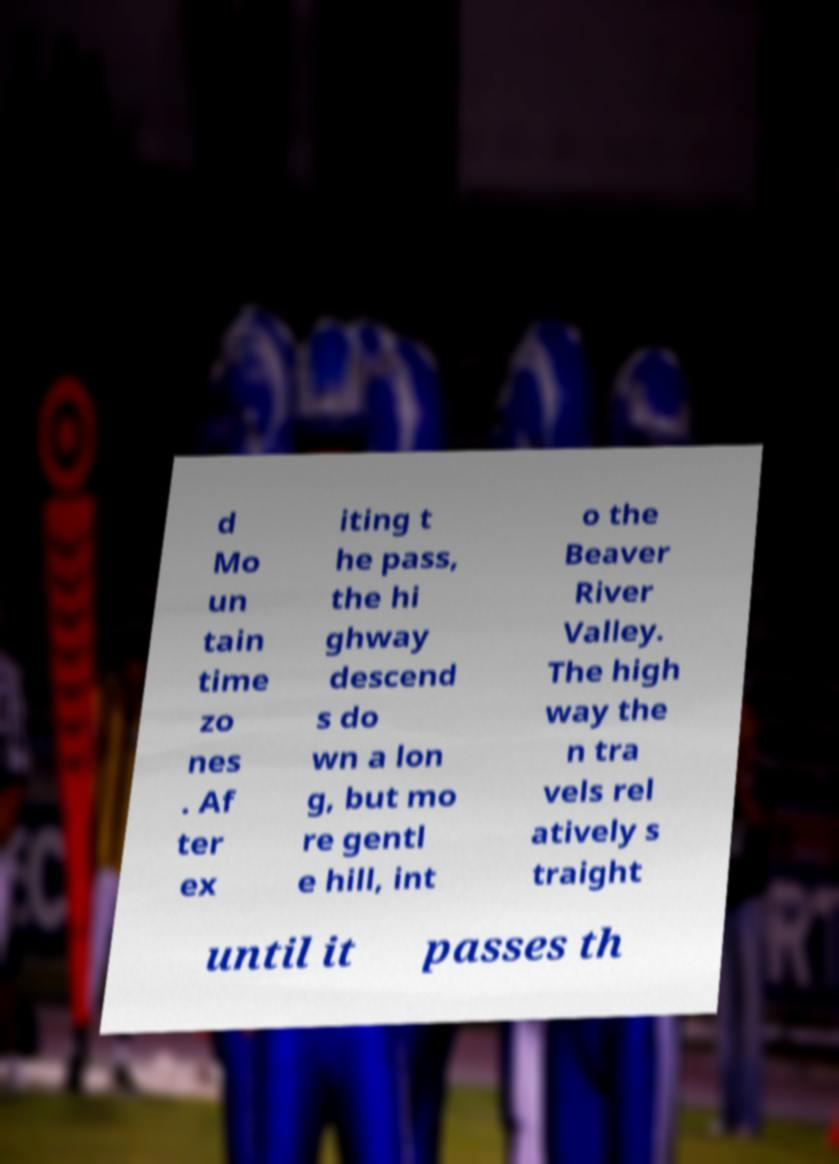Can you accurately transcribe the text from the provided image for me? d Mo un tain time zo nes . Af ter ex iting t he pass, the hi ghway descend s do wn a lon g, but mo re gentl e hill, int o the Beaver River Valley. The high way the n tra vels rel atively s traight until it passes th 